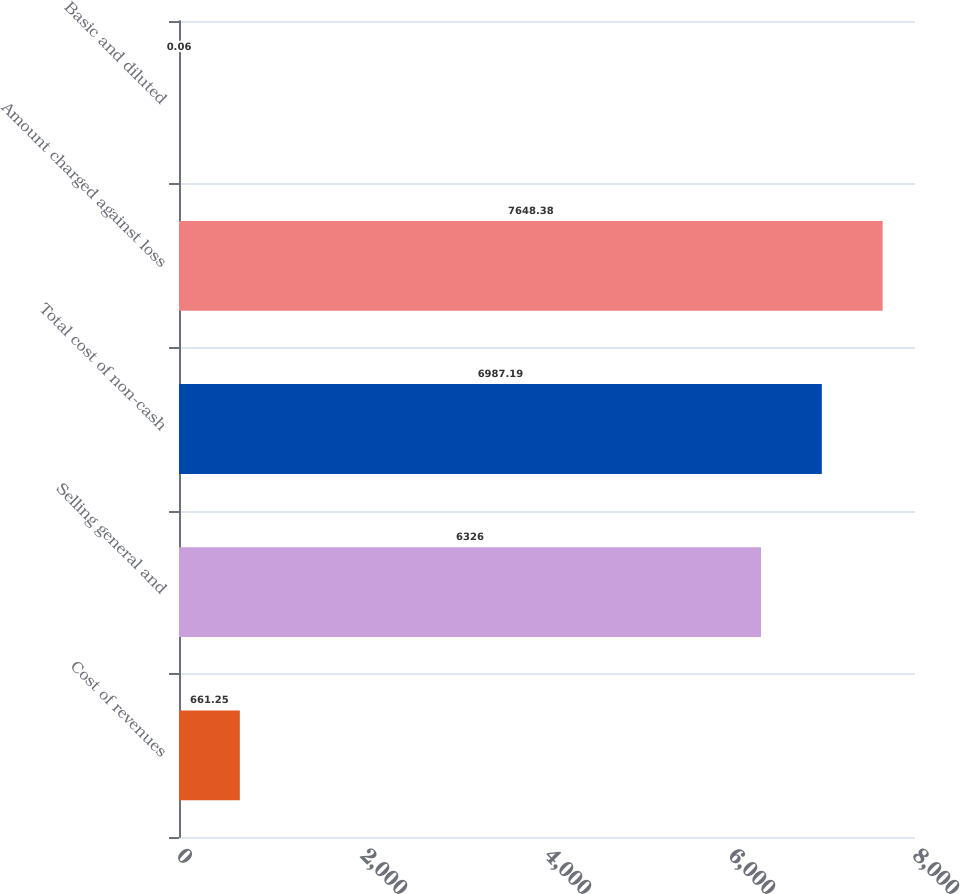<chart> <loc_0><loc_0><loc_500><loc_500><bar_chart><fcel>Cost of revenues<fcel>Selling general and<fcel>Total cost of non-cash<fcel>Amount charged against loss<fcel>Basic and diluted<nl><fcel>661.25<fcel>6326<fcel>6987.19<fcel>7648.38<fcel>0.06<nl></chart> 